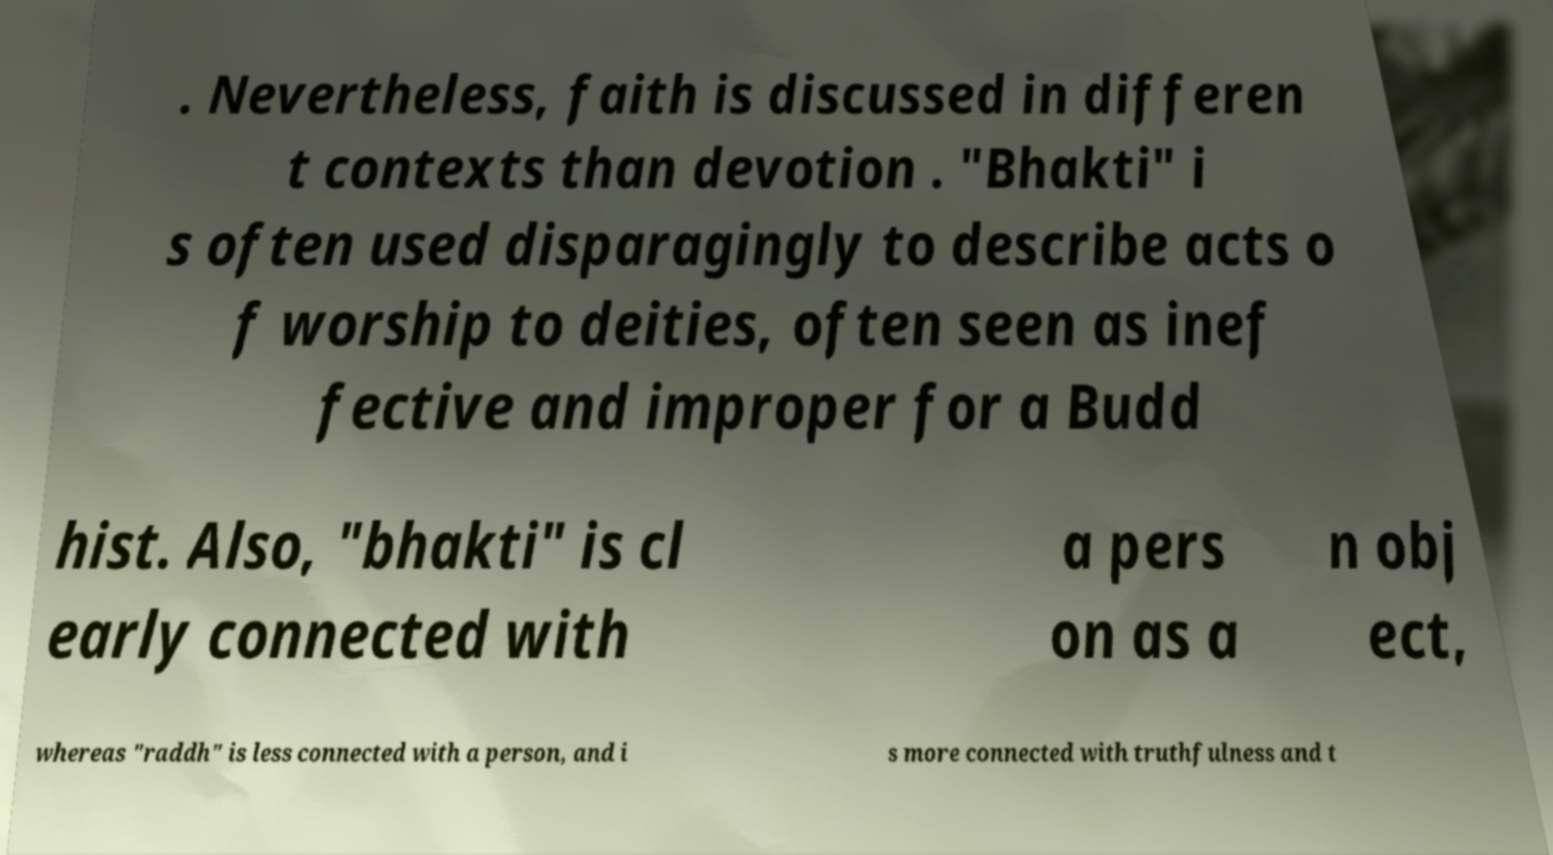Please identify and transcribe the text found in this image. . Nevertheless, faith is discussed in differen t contexts than devotion . "Bhakti" i s often used disparagingly to describe acts o f worship to deities, often seen as inef fective and improper for a Budd hist. Also, "bhakti" is cl early connected with a pers on as a n obj ect, whereas "raddh" is less connected with a person, and i s more connected with truthfulness and t 